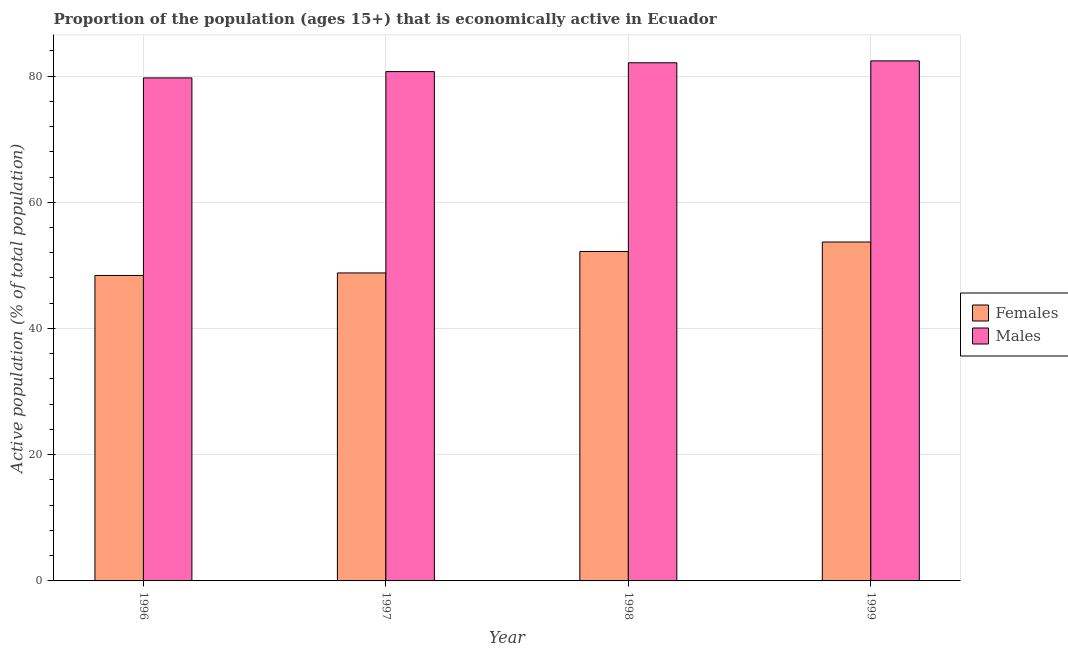Are the number of bars per tick equal to the number of legend labels?
Your answer should be compact. Yes. How many bars are there on the 2nd tick from the left?
Your answer should be compact. 2. How many bars are there on the 1st tick from the right?
Your response must be concise. 2. What is the label of the 4th group of bars from the left?
Offer a terse response. 1999. In how many cases, is the number of bars for a given year not equal to the number of legend labels?
Offer a very short reply. 0. What is the percentage of economically active female population in 1996?
Your response must be concise. 48.4. Across all years, what is the maximum percentage of economically active female population?
Give a very brief answer. 53.7. Across all years, what is the minimum percentage of economically active female population?
Your answer should be very brief. 48.4. In which year was the percentage of economically active male population maximum?
Ensure brevity in your answer.  1999. What is the total percentage of economically active male population in the graph?
Keep it short and to the point. 324.9. What is the difference between the percentage of economically active female population in 1996 and that in 1998?
Provide a short and direct response. -3.8. What is the difference between the percentage of economically active male population in 1998 and the percentage of economically active female population in 1999?
Offer a terse response. -0.3. What is the average percentage of economically active female population per year?
Ensure brevity in your answer.  50.78. What is the ratio of the percentage of economically active female population in 1996 to that in 1998?
Your response must be concise. 0.93. Is the percentage of economically active female population in 1996 less than that in 1998?
Offer a very short reply. Yes. What is the difference between the highest and the second highest percentage of economically active male population?
Your answer should be compact. 0.3. What is the difference between the highest and the lowest percentage of economically active female population?
Give a very brief answer. 5.3. What does the 2nd bar from the left in 1999 represents?
Make the answer very short. Males. What does the 2nd bar from the right in 1999 represents?
Your response must be concise. Females. How many bars are there?
Provide a succinct answer. 8. Are all the bars in the graph horizontal?
Make the answer very short. No. How many years are there in the graph?
Keep it short and to the point. 4. Are the values on the major ticks of Y-axis written in scientific E-notation?
Offer a terse response. No. Does the graph contain grids?
Provide a short and direct response. Yes. Where does the legend appear in the graph?
Give a very brief answer. Center right. How are the legend labels stacked?
Ensure brevity in your answer.  Vertical. What is the title of the graph?
Your response must be concise. Proportion of the population (ages 15+) that is economically active in Ecuador. Does "Commercial service imports" appear as one of the legend labels in the graph?
Offer a very short reply. No. What is the label or title of the X-axis?
Provide a succinct answer. Year. What is the label or title of the Y-axis?
Make the answer very short. Active population (% of total population). What is the Active population (% of total population) of Females in 1996?
Give a very brief answer. 48.4. What is the Active population (% of total population) in Males in 1996?
Your response must be concise. 79.7. What is the Active population (% of total population) in Females in 1997?
Ensure brevity in your answer.  48.8. What is the Active population (% of total population) in Males in 1997?
Ensure brevity in your answer.  80.7. What is the Active population (% of total population) of Females in 1998?
Offer a terse response. 52.2. What is the Active population (% of total population) in Males in 1998?
Provide a short and direct response. 82.1. What is the Active population (% of total population) in Females in 1999?
Provide a succinct answer. 53.7. What is the Active population (% of total population) in Males in 1999?
Your answer should be very brief. 82.4. Across all years, what is the maximum Active population (% of total population) in Females?
Keep it short and to the point. 53.7. Across all years, what is the maximum Active population (% of total population) of Males?
Provide a short and direct response. 82.4. Across all years, what is the minimum Active population (% of total population) of Females?
Your answer should be very brief. 48.4. Across all years, what is the minimum Active population (% of total population) of Males?
Provide a succinct answer. 79.7. What is the total Active population (% of total population) in Females in the graph?
Ensure brevity in your answer.  203.1. What is the total Active population (% of total population) in Males in the graph?
Your answer should be compact. 324.9. What is the difference between the Active population (% of total population) of Males in 1996 and that in 1997?
Give a very brief answer. -1. What is the difference between the Active population (% of total population) of Females in 1996 and that in 1998?
Provide a short and direct response. -3.8. What is the difference between the Active population (% of total population) in Males in 1996 and that in 1998?
Offer a terse response. -2.4. What is the difference between the Active population (% of total population) of Males in 1996 and that in 1999?
Offer a very short reply. -2.7. What is the difference between the Active population (% of total population) in Males in 1997 and that in 1998?
Ensure brevity in your answer.  -1.4. What is the difference between the Active population (% of total population) in Males in 1997 and that in 1999?
Keep it short and to the point. -1.7. What is the difference between the Active population (% of total population) of Females in 1998 and that in 1999?
Keep it short and to the point. -1.5. What is the difference between the Active population (% of total population) of Males in 1998 and that in 1999?
Ensure brevity in your answer.  -0.3. What is the difference between the Active population (% of total population) in Females in 1996 and the Active population (% of total population) in Males in 1997?
Provide a short and direct response. -32.3. What is the difference between the Active population (% of total population) of Females in 1996 and the Active population (% of total population) of Males in 1998?
Offer a very short reply. -33.7. What is the difference between the Active population (% of total population) of Females in 1996 and the Active population (% of total population) of Males in 1999?
Provide a short and direct response. -34. What is the difference between the Active population (% of total population) in Females in 1997 and the Active population (% of total population) in Males in 1998?
Make the answer very short. -33.3. What is the difference between the Active population (% of total population) of Females in 1997 and the Active population (% of total population) of Males in 1999?
Offer a very short reply. -33.6. What is the difference between the Active population (% of total population) of Females in 1998 and the Active population (% of total population) of Males in 1999?
Ensure brevity in your answer.  -30.2. What is the average Active population (% of total population) of Females per year?
Offer a terse response. 50.77. What is the average Active population (% of total population) in Males per year?
Offer a very short reply. 81.22. In the year 1996, what is the difference between the Active population (% of total population) in Females and Active population (% of total population) in Males?
Provide a short and direct response. -31.3. In the year 1997, what is the difference between the Active population (% of total population) in Females and Active population (% of total population) in Males?
Your answer should be very brief. -31.9. In the year 1998, what is the difference between the Active population (% of total population) in Females and Active population (% of total population) in Males?
Keep it short and to the point. -29.9. In the year 1999, what is the difference between the Active population (% of total population) of Females and Active population (% of total population) of Males?
Keep it short and to the point. -28.7. What is the ratio of the Active population (% of total population) in Females in 1996 to that in 1997?
Your answer should be compact. 0.99. What is the ratio of the Active population (% of total population) of Males in 1996 to that in 1997?
Offer a terse response. 0.99. What is the ratio of the Active population (% of total population) of Females in 1996 to that in 1998?
Ensure brevity in your answer.  0.93. What is the ratio of the Active population (% of total population) in Males in 1996 to that in 1998?
Your answer should be very brief. 0.97. What is the ratio of the Active population (% of total population) of Females in 1996 to that in 1999?
Give a very brief answer. 0.9. What is the ratio of the Active population (% of total population) in Males in 1996 to that in 1999?
Offer a terse response. 0.97. What is the ratio of the Active population (% of total population) in Females in 1997 to that in 1998?
Provide a succinct answer. 0.93. What is the ratio of the Active population (% of total population) of Males in 1997 to that in 1998?
Give a very brief answer. 0.98. What is the ratio of the Active population (% of total population) of Females in 1997 to that in 1999?
Provide a short and direct response. 0.91. What is the ratio of the Active population (% of total population) in Males in 1997 to that in 1999?
Offer a terse response. 0.98. What is the ratio of the Active population (% of total population) of Females in 1998 to that in 1999?
Make the answer very short. 0.97. What is the difference between the highest and the lowest Active population (% of total population) in Females?
Your answer should be compact. 5.3. What is the difference between the highest and the lowest Active population (% of total population) in Males?
Give a very brief answer. 2.7. 